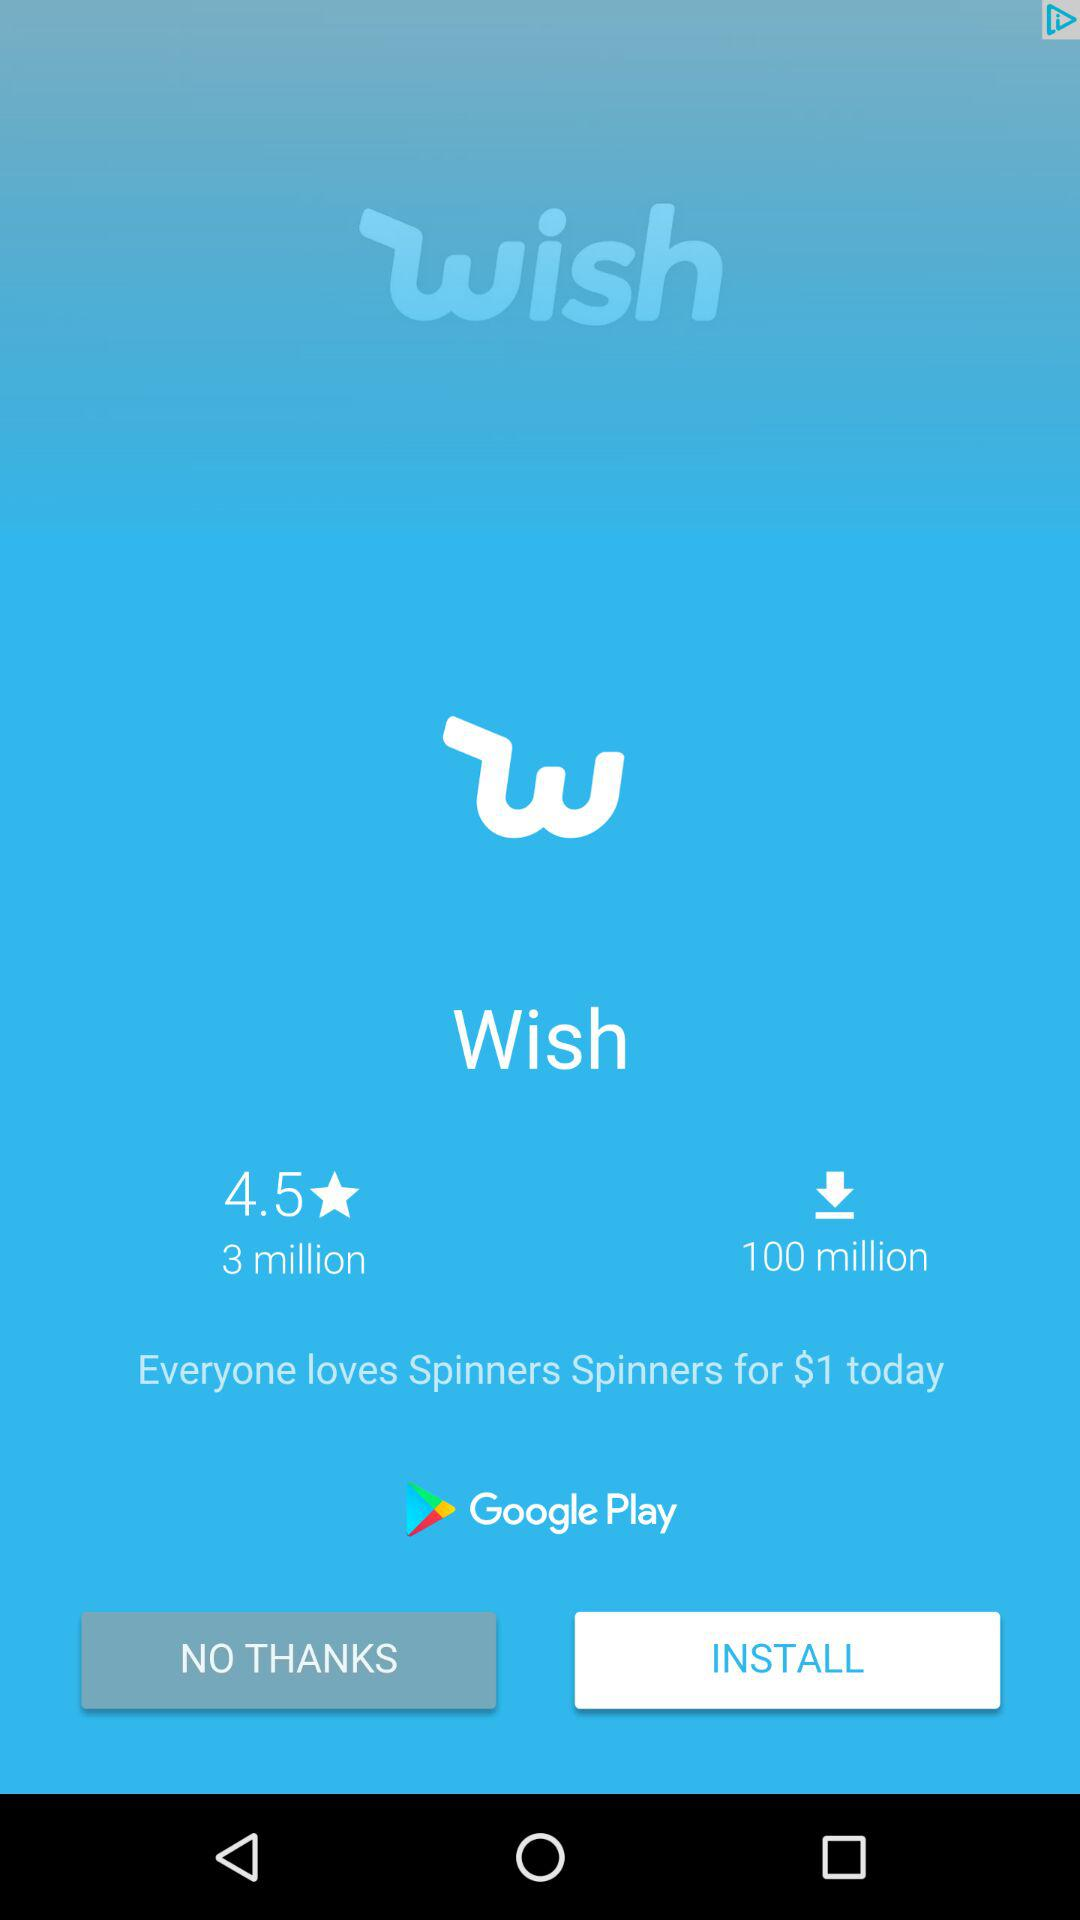How many more downloads does the app have than reviews?
Answer the question using a single word or phrase. 97 million 